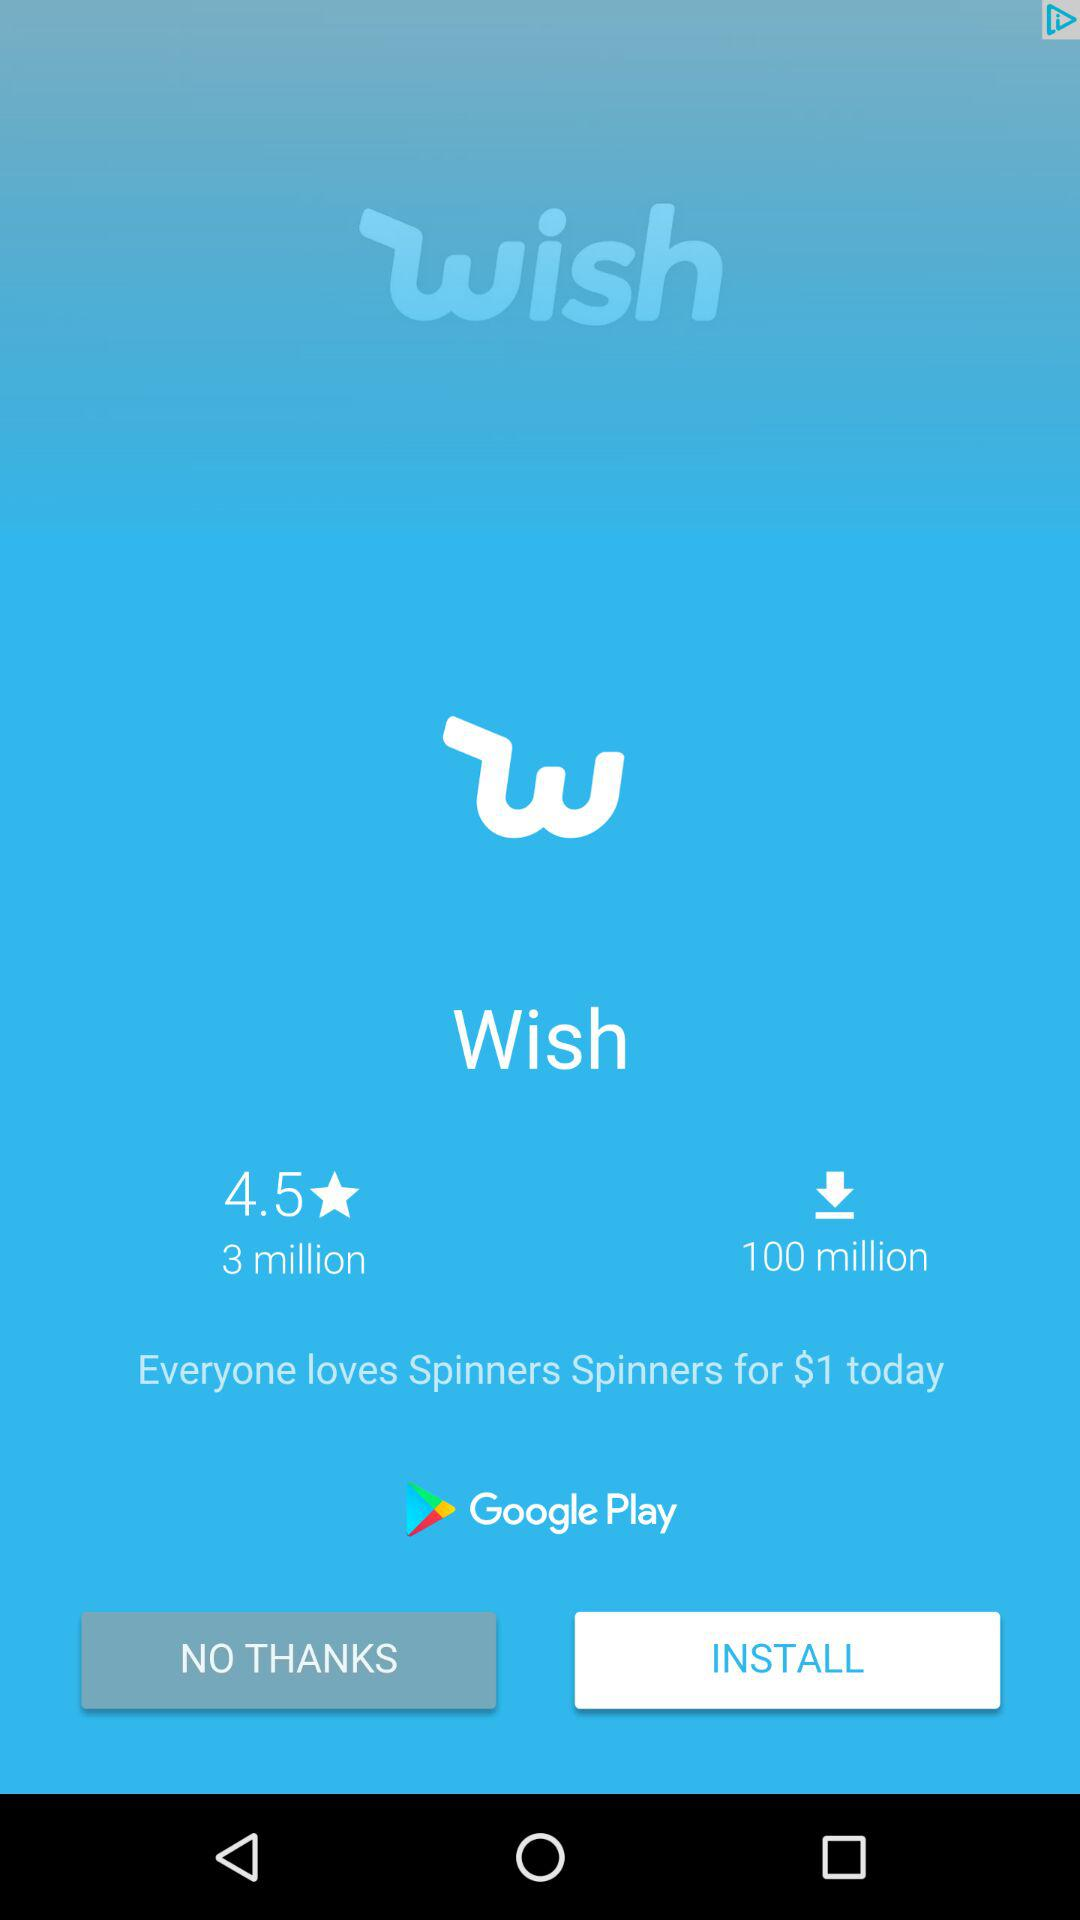How many more downloads does the app have than reviews?
Answer the question using a single word or phrase. 97 million 